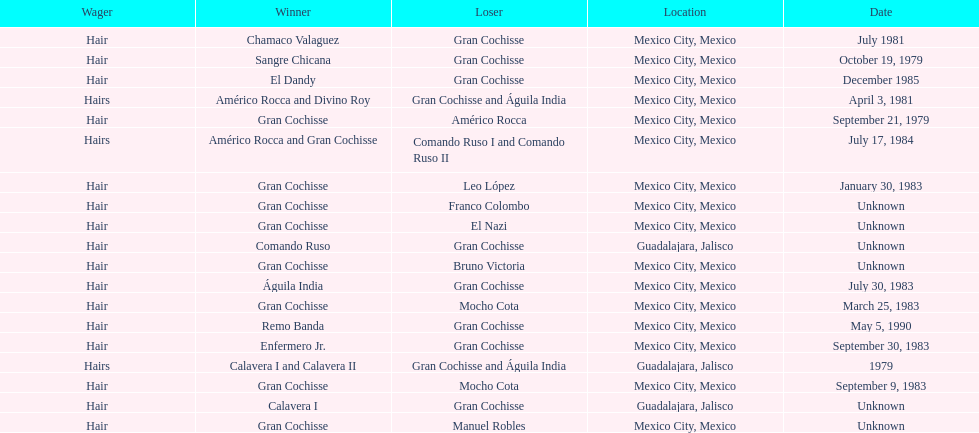How many games more than chamaco valaguez did sangre chicana win? 0. 